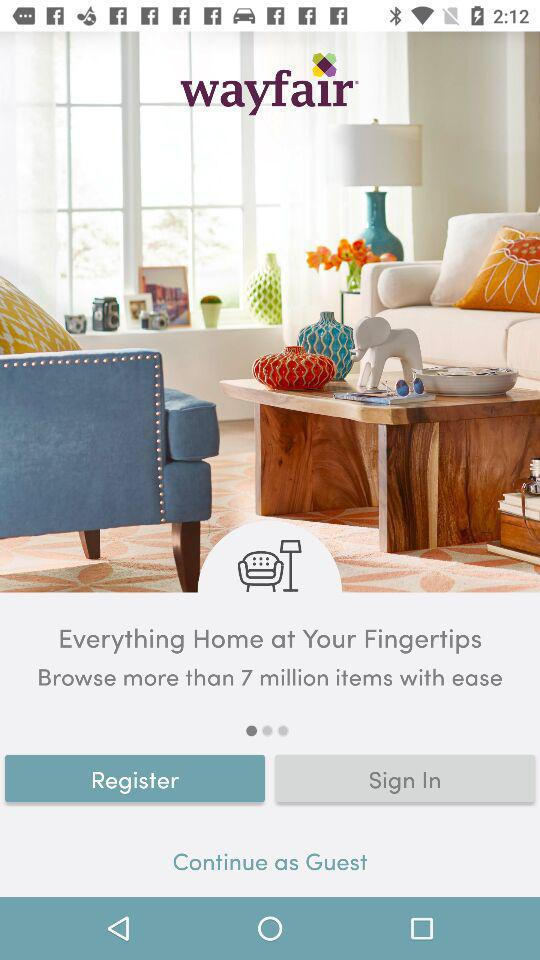What is the user name?
When the provided information is insufficient, respond with <no answer>. <no answer> 